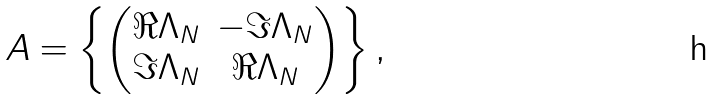<formula> <loc_0><loc_0><loc_500><loc_500>A = \left \{ \begin{pmatrix} \Re \Lambda _ { N } & - \Im \Lambda _ { N } \\ \Im \Lambda _ { N } & \Re \Lambda _ { N } \end{pmatrix} \right \} ,</formula> 